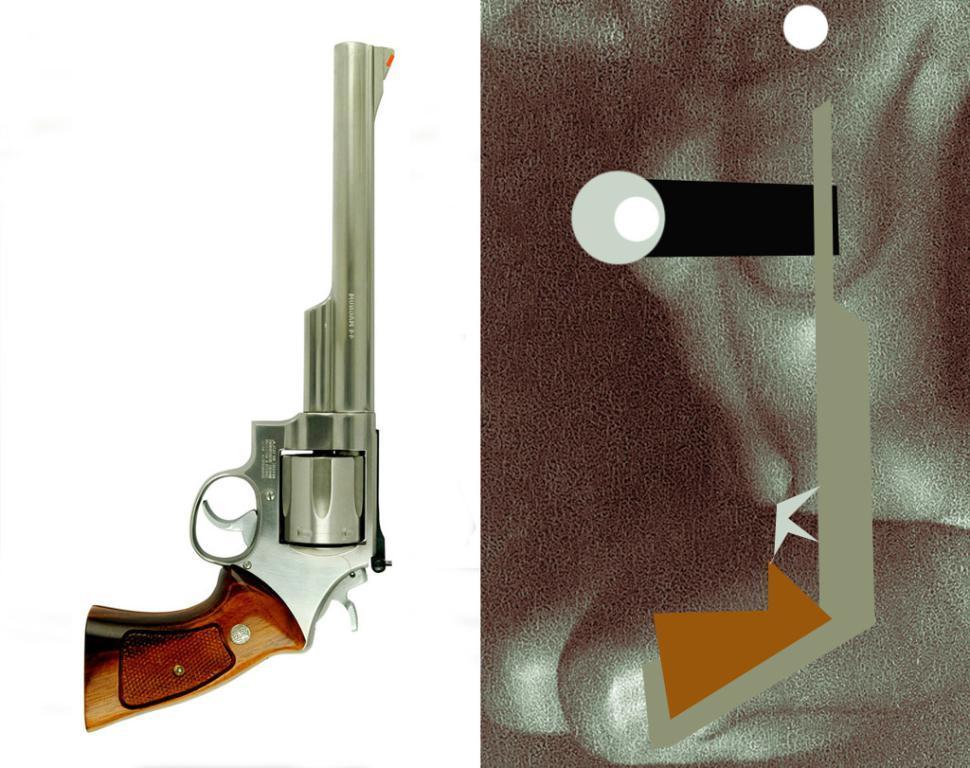Please provide a concise description of this image. In this image I can see the collage picture and I can see the gun and the outline of the gun and the background is in white and black color. 